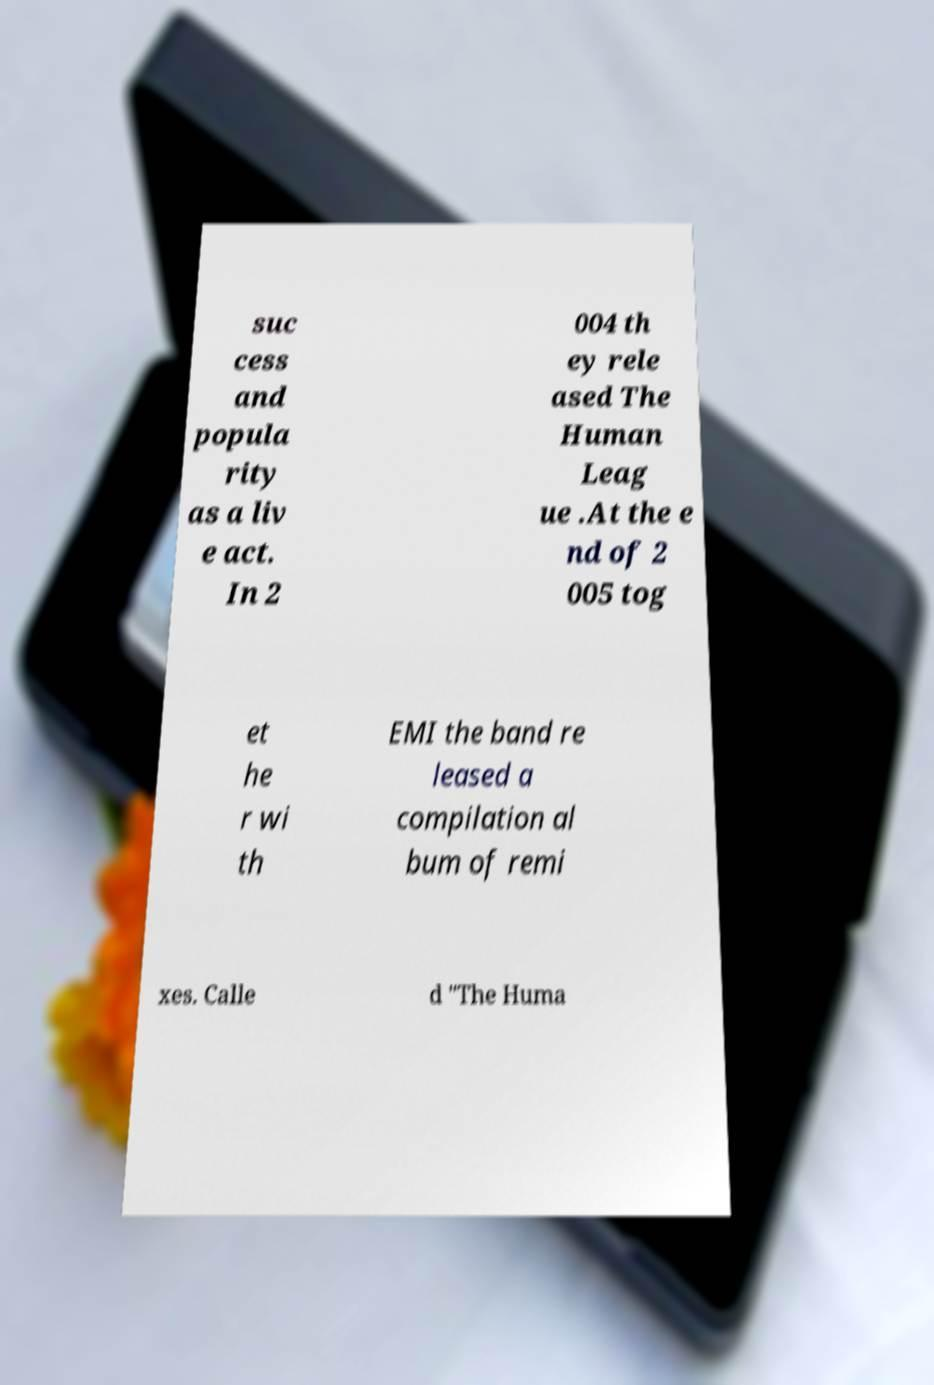I need the written content from this picture converted into text. Can you do that? suc cess and popula rity as a liv e act. In 2 004 th ey rele ased The Human Leag ue .At the e nd of 2 005 tog et he r wi th EMI the band re leased a compilation al bum of remi xes. Calle d "The Huma 